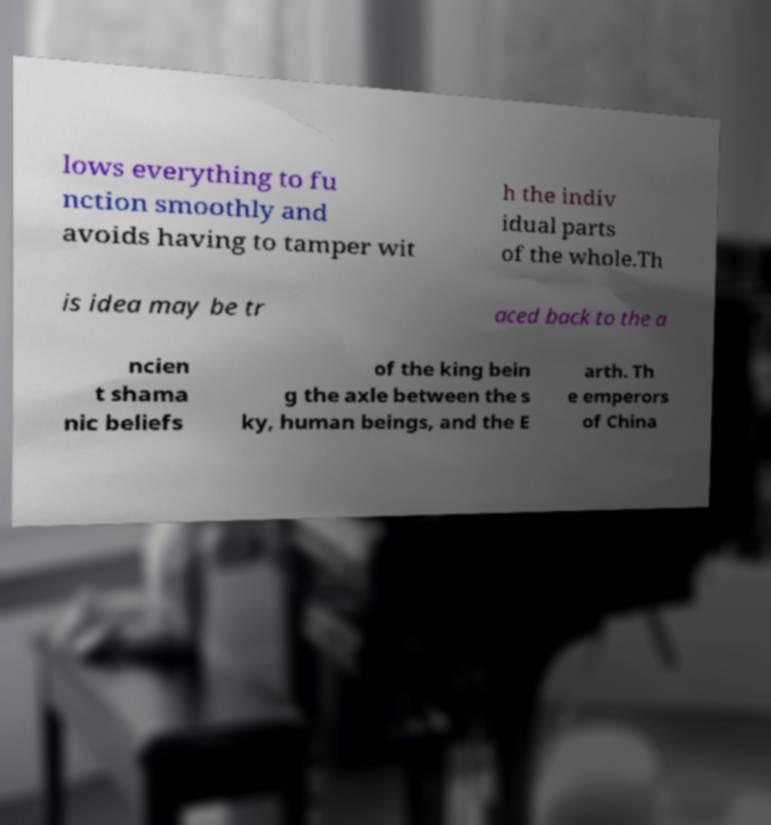Could you extract and type out the text from this image? lows everything to fu nction smoothly and avoids having to tamper wit h the indiv idual parts of the whole.Th is idea may be tr aced back to the a ncien t shama nic beliefs of the king bein g the axle between the s ky, human beings, and the E arth. Th e emperors of China 